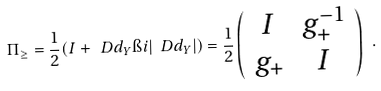Convert formula to latex. <formula><loc_0><loc_0><loc_500><loc_500>\Pi _ { \geq } = \frac { 1 } { 2 } ( I + \ D d _ { Y } \i i | \ D d _ { Y } | ) = \frac { 1 } { 2 } \left ( \begin{array} { c c } I & g _ { + } ^ { - 1 } \\ g _ { + } & I \end{array} \right ) \ .</formula> 